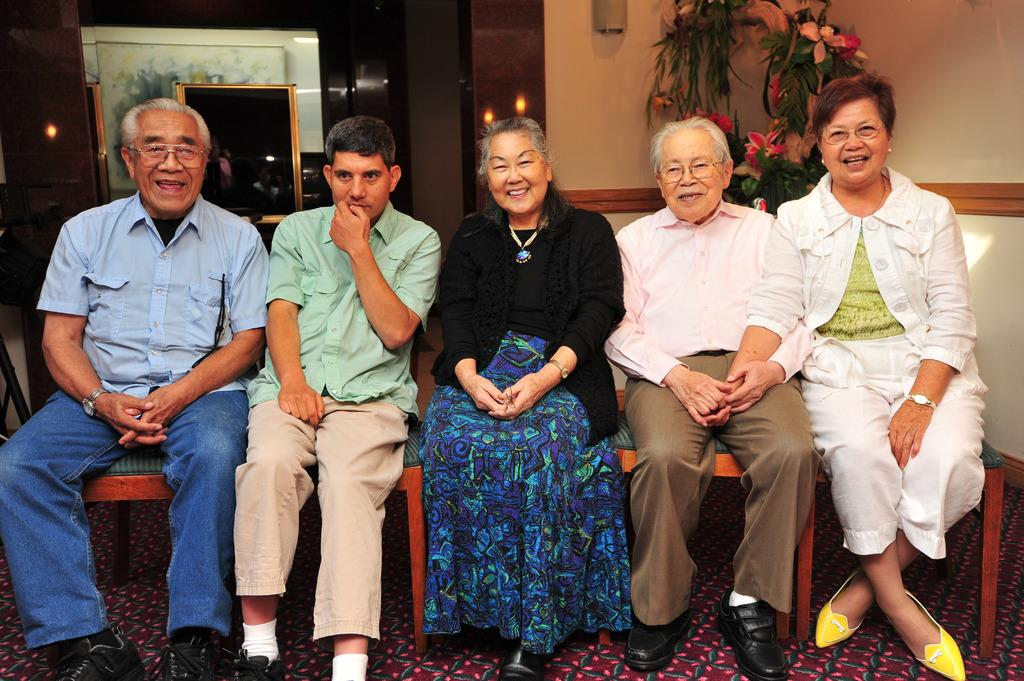What are the people in the image doing? The people in the image are sitting in the center. What can be seen in the background of the image? There are portraits and flowers in the background of the image. What type of attraction can be seen in the image? There is no attraction present in the image; it features people sitting and portraits and flowers in the background. What is the slope of the hill in the image? There is no hill or slope present in the image. 